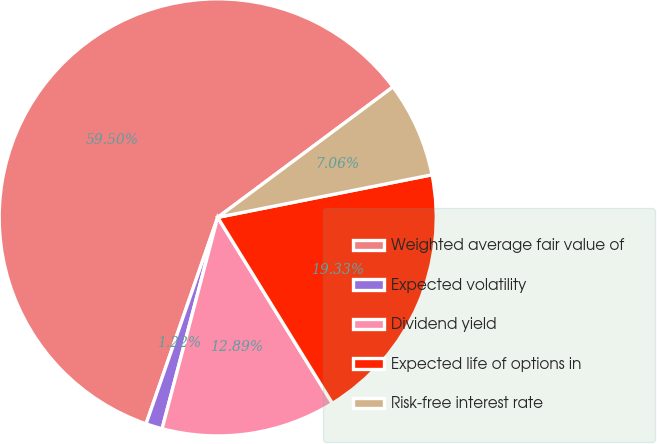<chart> <loc_0><loc_0><loc_500><loc_500><pie_chart><fcel>Weighted average fair value of<fcel>Expected volatility<fcel>Dividend yield<fcel>Expected life of options in<fcel>Risk-free interest rate<nl><fcel>59.5%<fcel>1.22%<fcel>12.89%<fcel>19.33%<fcel>7.06%<nl></chart> 